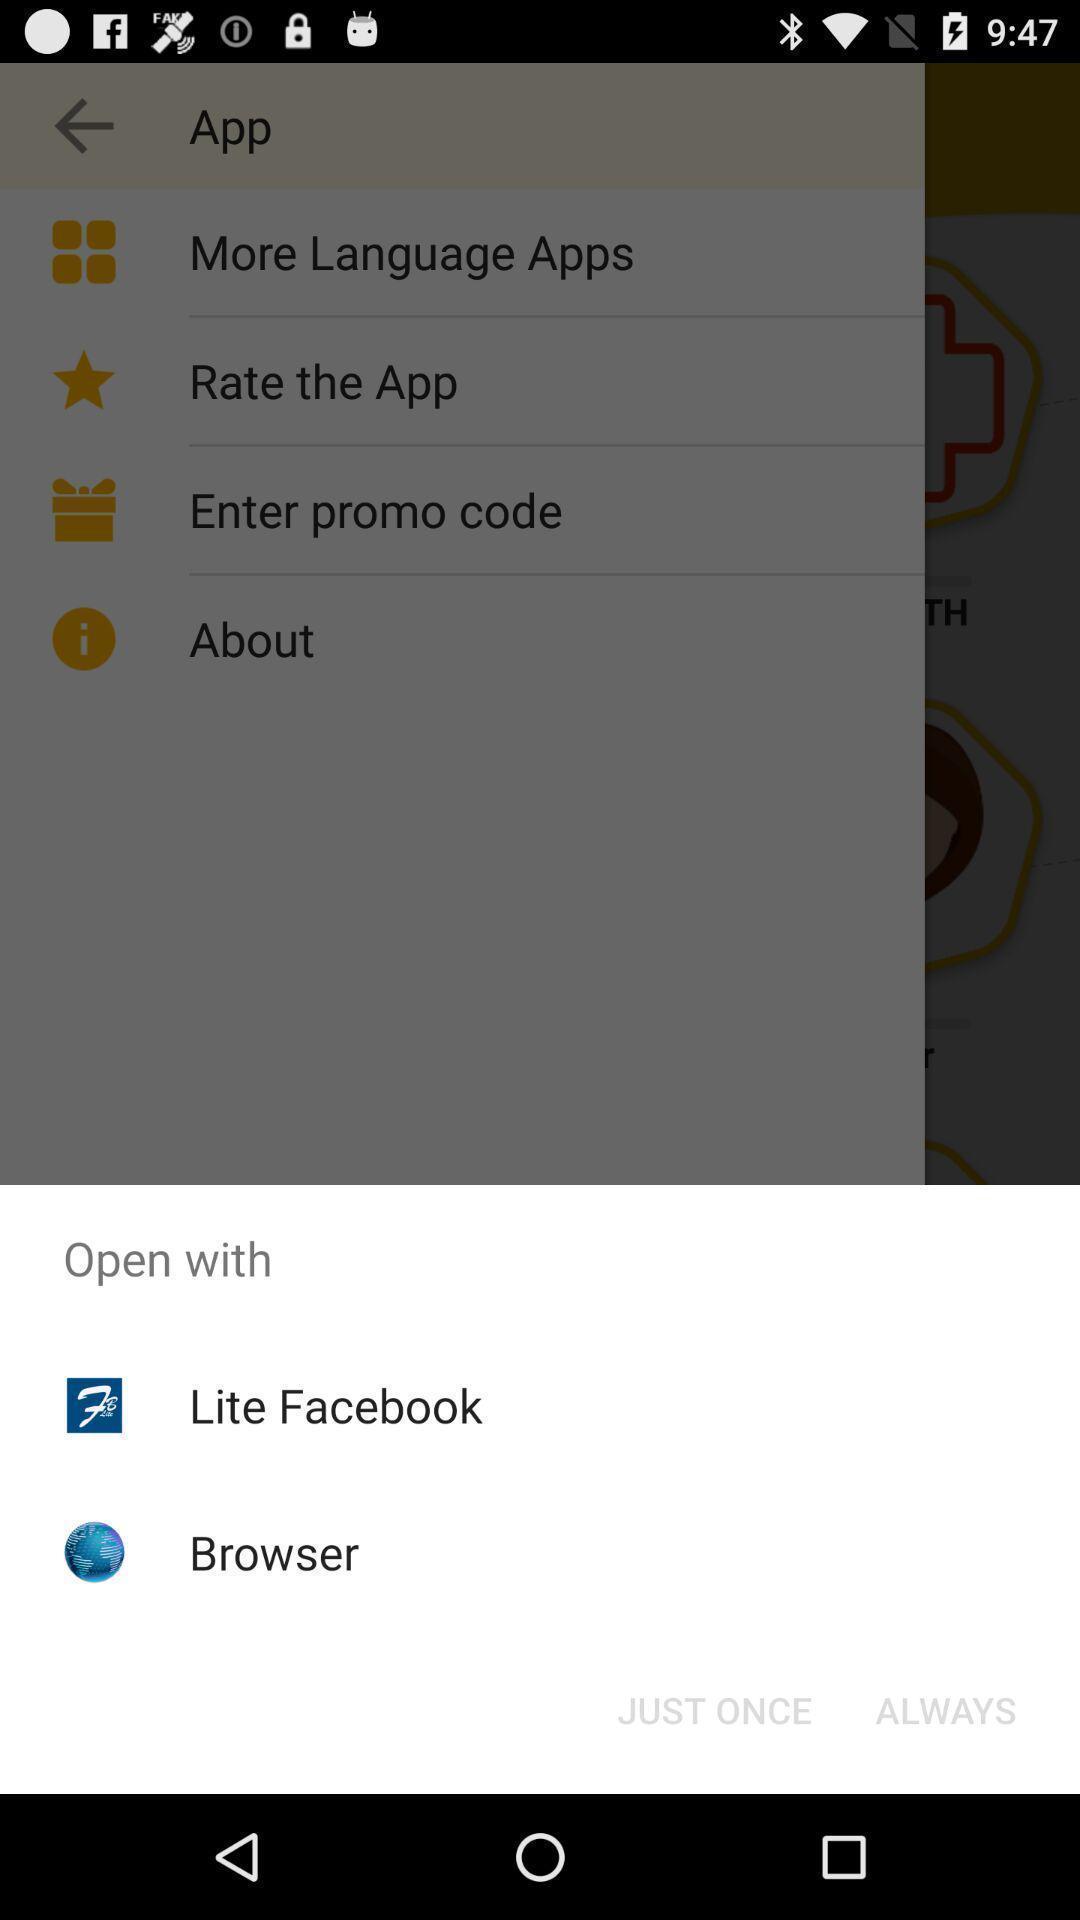Describe the key features of this screenshot. Pop-up of icons to open a language app. 